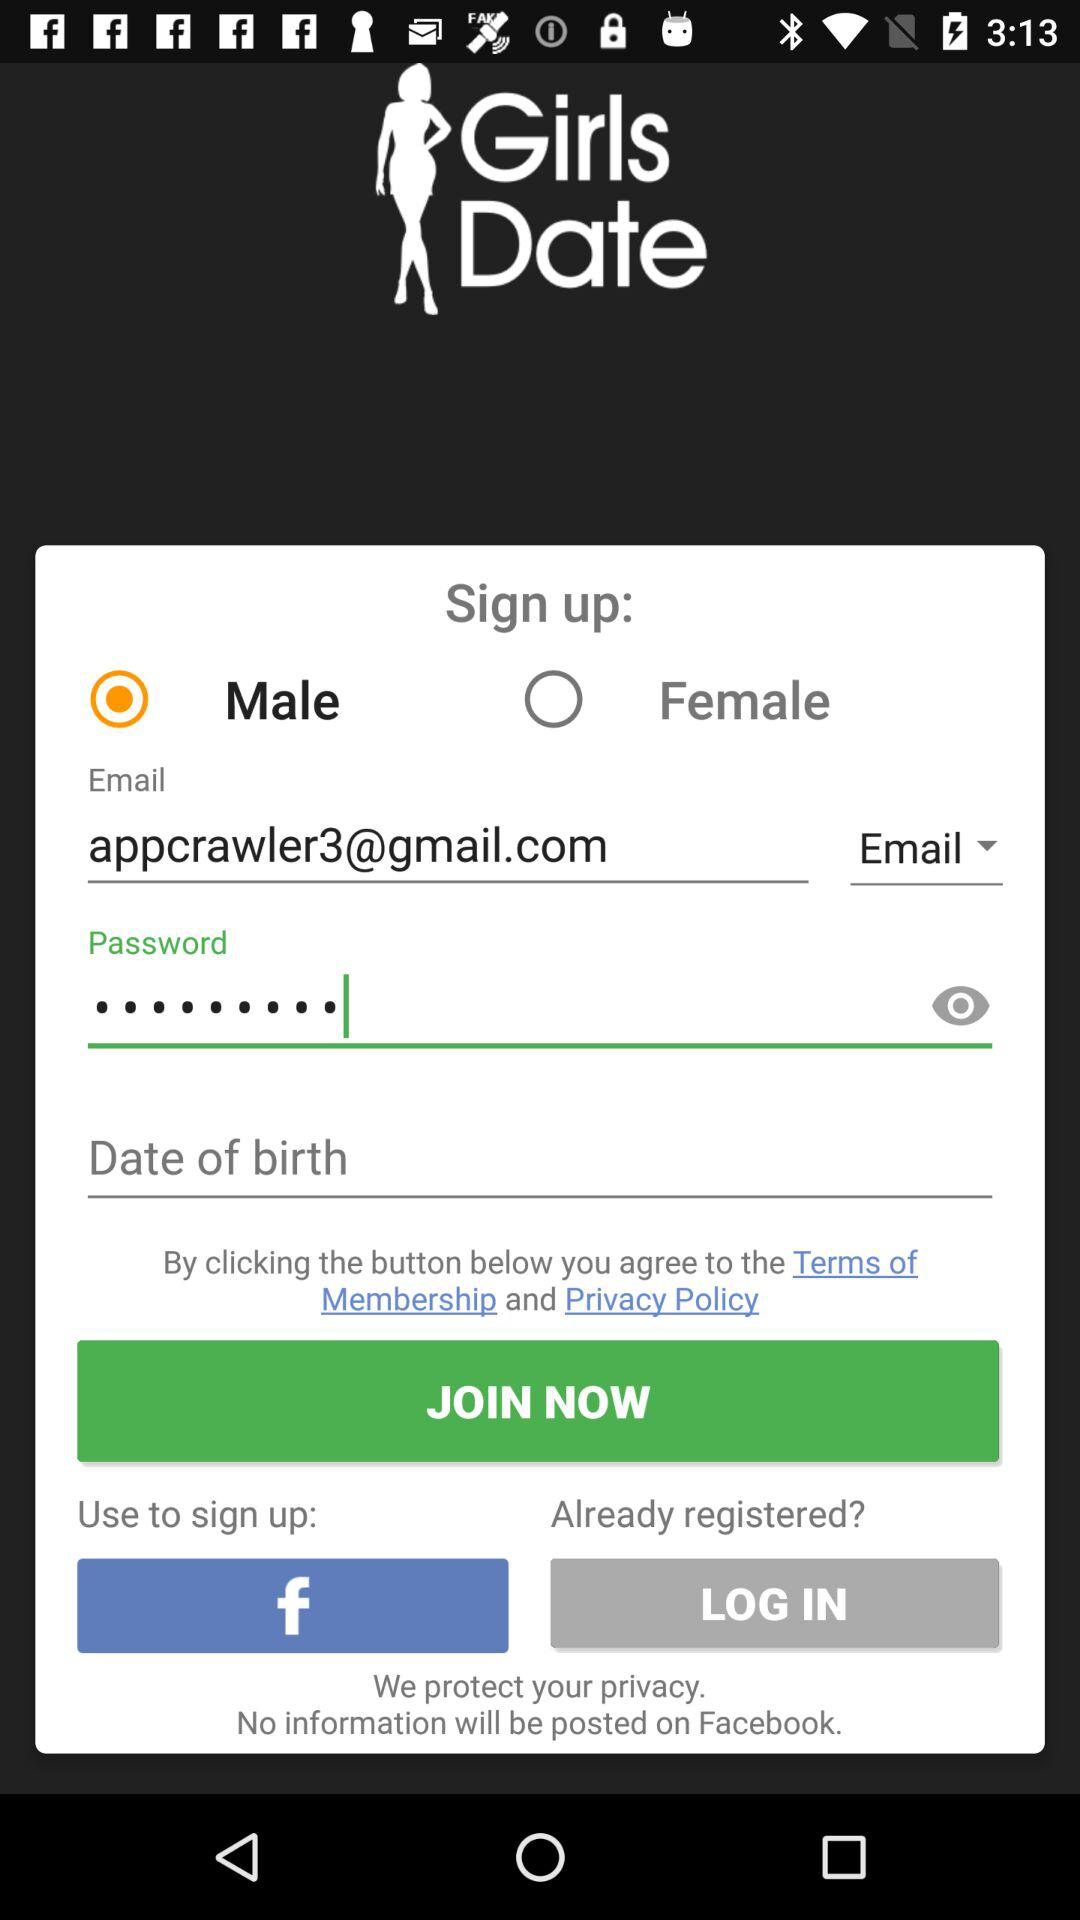Which option is selected in the gender? The selected option is "Male". 